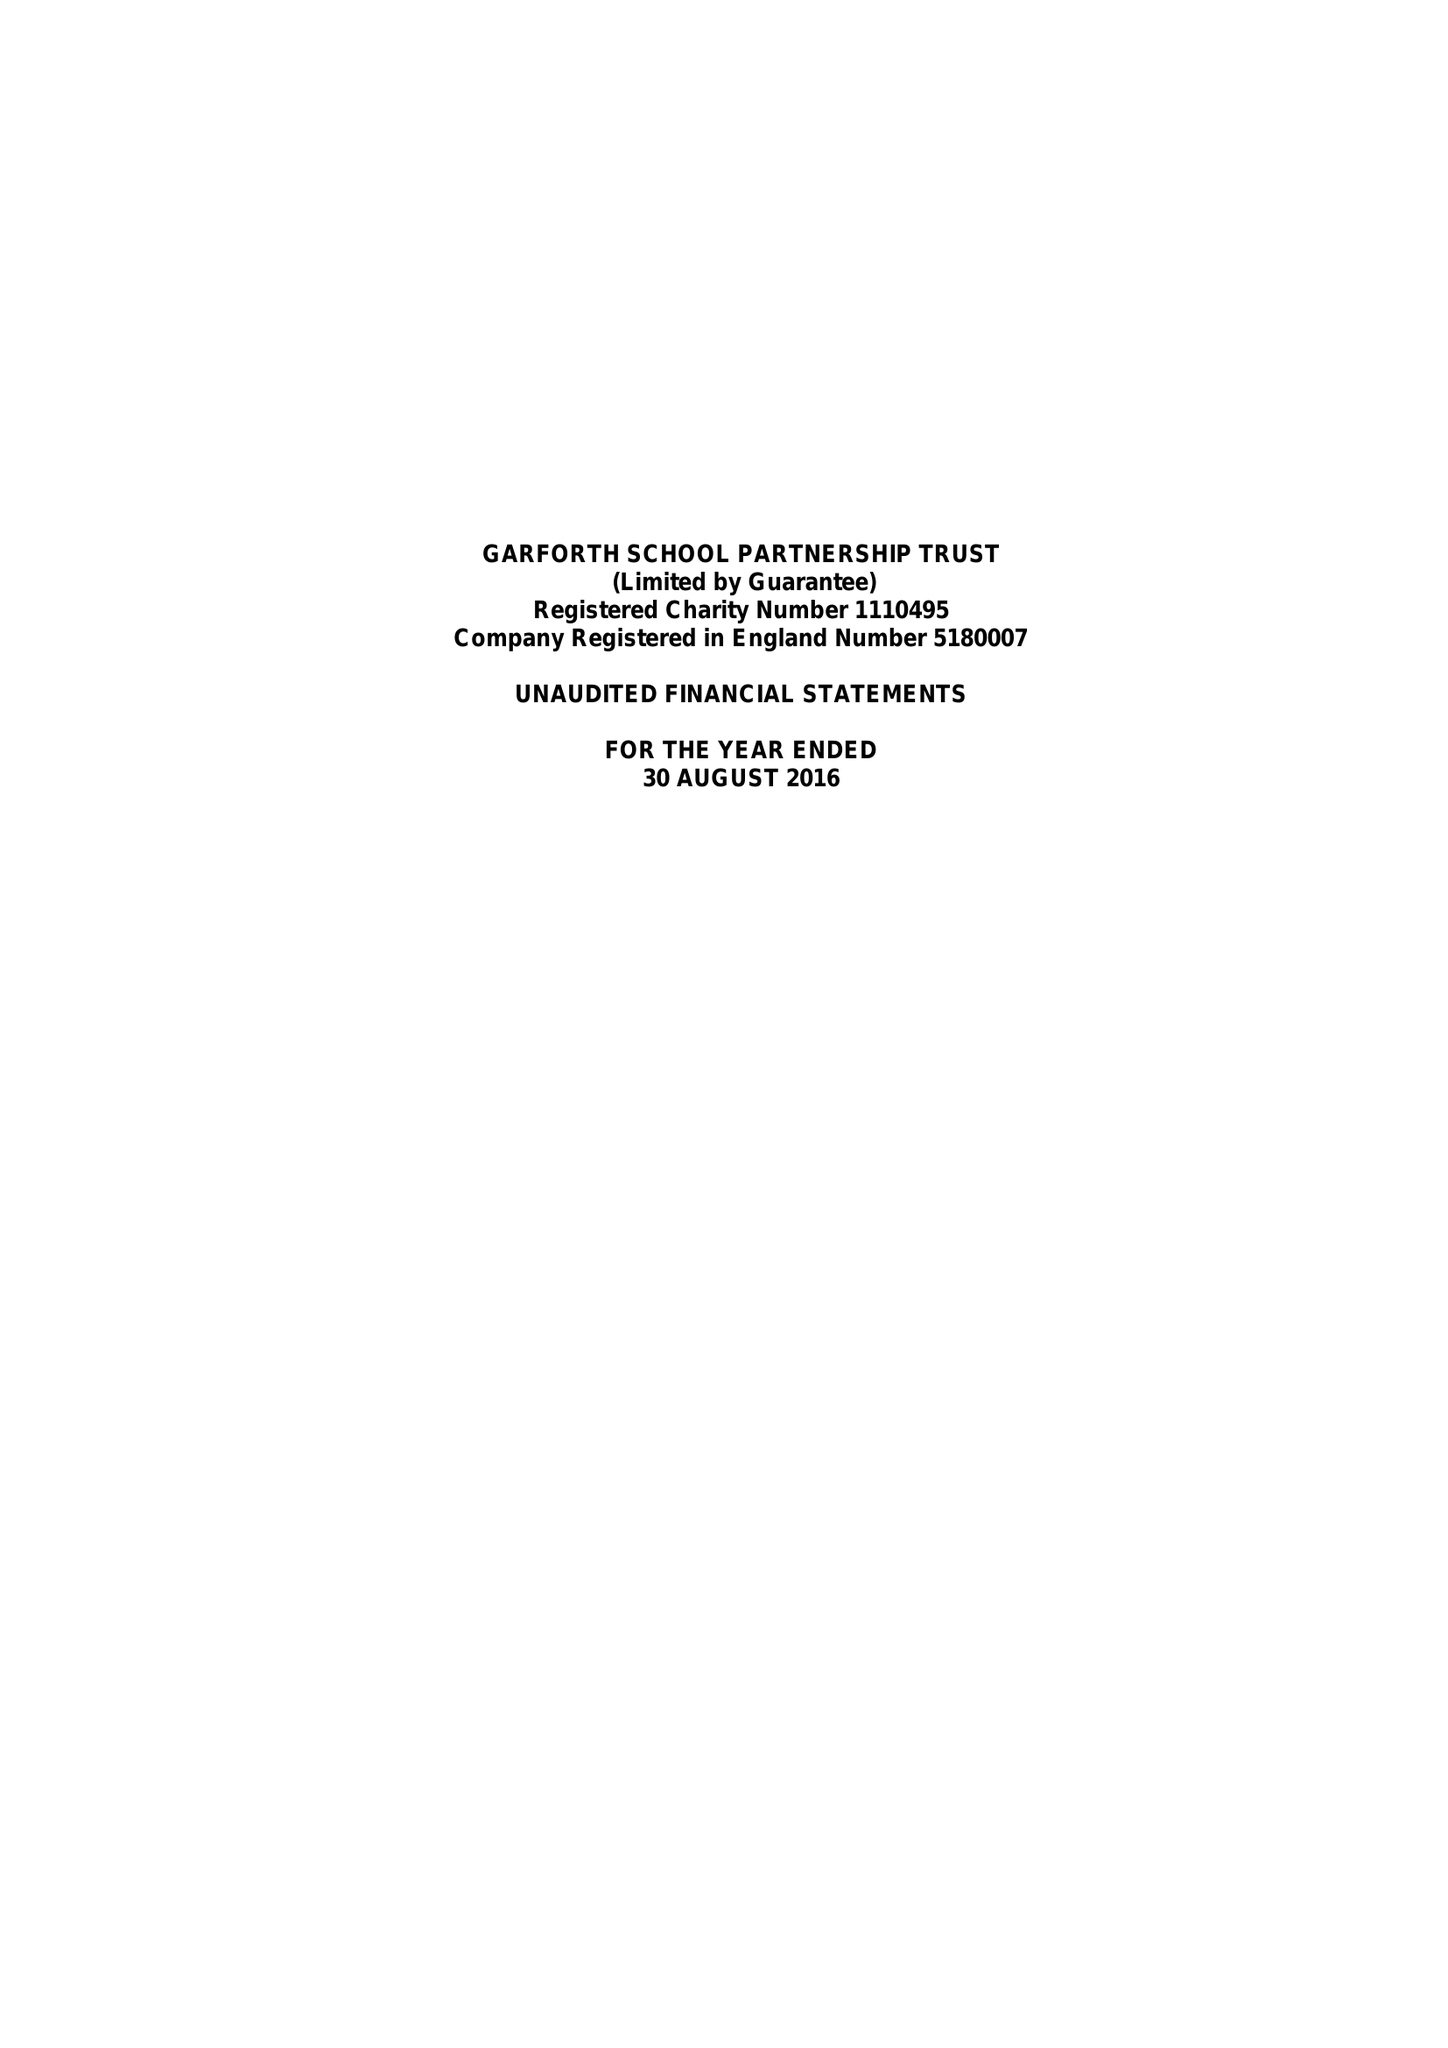What is the value for the address__street_line?
Answer the question using a single word or phrase. LIDGETT LANE 